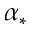Convert formula to latex. <formula><loc_0><loc_0><loc_500><loc_500>\alpha _ { * }</formula> 